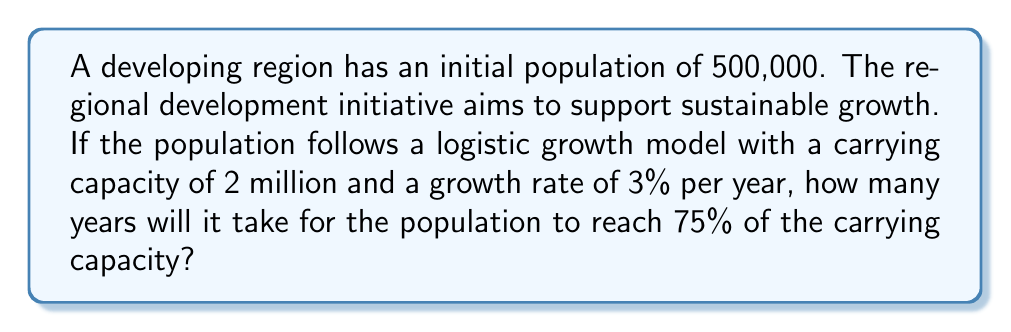Can you answer this question? Let's approach this step-by-step using the logistic growth model:

1) The logistic growth model is given by the equation:

   $$P(t) = \frac{K}{1 + (\frac{K}{P_0} - 1)e^{-rt}}$$

   Where:
   $P(t)$ is the population at time $t$
   $K$ is the carrying capacity
   $P_0$ is the initial population
   $r$ is the growth rate
   $t$ is the time in years

2) We're given:
   $K = 2,000,000$
   $P_0 = 500,000$
   $r = 0.03$ (3% per year)

3) We want to find $t$ when $P(t) = 75\%$ of $K$, which is $1,500,000$

4) Substituting these values into the equation:

   $$1,500,000 = \frac{2,000,000}{1 + (\frac{2,000,000}{500,000} - 1)e^{-0.03t}}$$

5) Simplify:

   $$1,500,000 = \frac{2,000,000}{1 + 3e^{-0.03t}}$$

6) Solve for $t$:
   
   $$\frac{2,000,000}{1,500,000} = 1 + 3e^{-0.03t}$$
   
   $$\frac{4}{3} = 1 + 3e^{-0.03t}$$
   
   $$\frac{1}{3} = 3e^{-0.03t}$$
   
   $$\frac{1}{9} = e^{-0.03t}$$
   
   $$\ln(\frac{1}{9}) = -0.03t$$
   
   $$\frac{\ln(9)}{0.03} = t$$

7) Calculate:
   
   $$t \approx 73.69$$

Therefore, it will take approximately 74 years for the population to reach 75% of the carrying capacity.
Answer: 74 years 